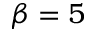<formula> <loc_0><loc_0><loc_500><loc_500>\beta = 5</formula> 